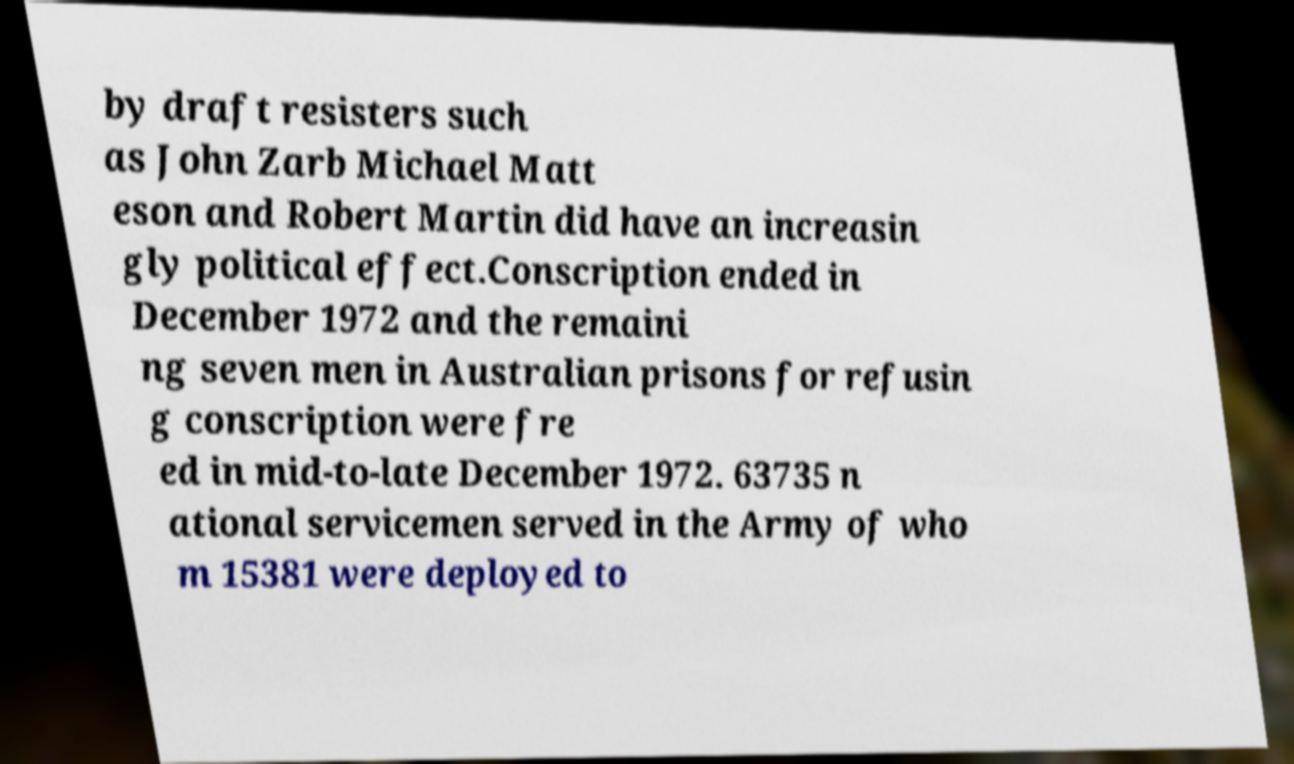What messages or text are displayed in this image? I need them in a readable, typed format. by draft resisters such as John Zarb Michael Matt eson and Robert Martin did have an increasin gly political effect.Conscription ended in December 1972 and the remaini ng seven men in Australian prisons for refusin g conscription were fre ed in mid-to-late December 1972. 63735 n ational servicemen served in the Army of who m 15381 were deployed to 